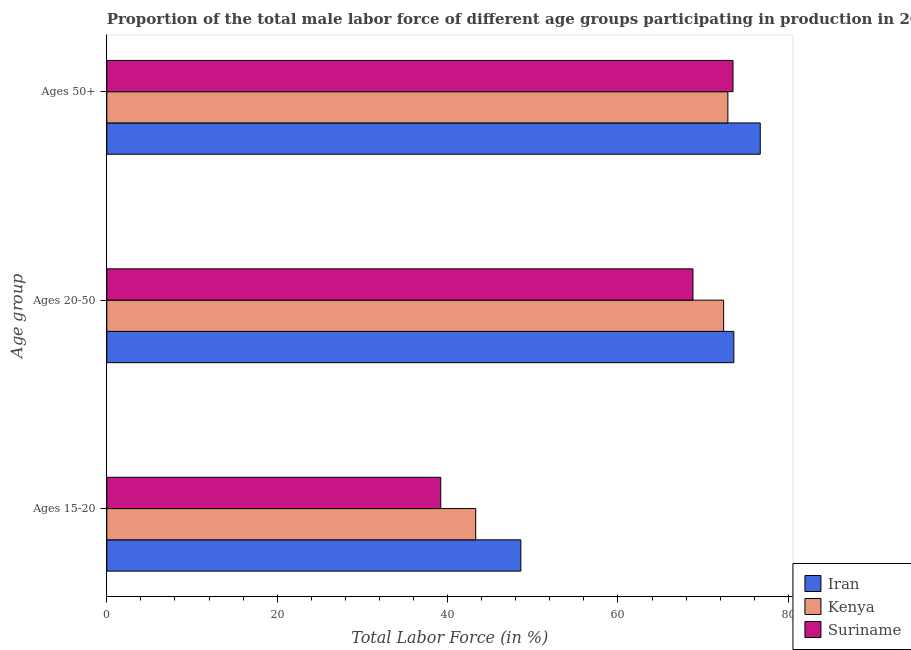How many different coloured bars are there?
Ensure brevity in your answer.  3. How many bars are there on the 1st tick from the bottom?
Offer a terse response. 3. What is the label of the 3rd group of bars from the top?
Make the answer very short. Ages 15-20. What is the percentage of male labor force within the age group 15-20 in Kenya?
Provide a succinct answer. 43.3. Across all countries, what is the maximum percentage of male labor force within the age group 15-20?
Provide a succinct answer. 48.6. Across all countries, what is the minimum percentage of male labor force within the age group 20-50?
Your answer should be compact. 68.8. In which country was the percentage of male labor force within the age group 15-20 maximum?
Provide a short and direct response. Iran. In which country was the percentage of male labor force above age 50 minimum?
Offer a terse response. Kenya. What is the total percentage of male labor force within the age group 20-50 in the graph?
Provide a short and direct response. 214.8. What is the difference between the percentage of male labor force within the age group 15-20 in Iran and that in Suriname?
Offer a very short reply. 9.4. What is the difference between the percentage of male labor force within the age group 20-50 in Suriname and the percentage of male labor force above age 50 in Iran?
Offer a very short reply. -7.9. What is the average percentage of male labor force within the age group 20-50 per country?
Your answer should be compact. 71.6. What is the difference between the percentage of male labor force within the age group 20-50 and percentage of male labor force above age 50 in Iran?
Make the answer very short. -3.1. What is the ratio of the percentage of male labor force within the age group 15-20 in Suriname to that in Iran?
Make the answer very short. 0.81. Is the percentage of male labor force within the age group 15-20 in Suriname less than that in Iran?
Your answer should be compact. Yes. Is the difference between the percentage of male labor force within the age group 20-50 in Suriname and Iran greater than the difference between the percentage of male labor force above age 50 in Suriname and Iran?
Provide a succinct answer. No. What is the difference between the highest and the second highest percentage of male labor force within the age group 20-50?
Your answer should be compact. 1.2. What is the difference between the highest and the lowest percentage of male labor force above age 50?
Make the answer very short. 3.8. In how many countries, is the percentage of male labor force above age 50 greater than the average percentage of male labor force above age 50 taken over all countries?
Give a very brief answer. 1. Is the sum of the percentage of male labor force above age 50 in Kenya and Suriname greater than the maximum percentage of male labor force within the age group 20-50 across all countries?
Keep it short and to the point. Yes. What does the 2nd bar from the top in Ages 20-50 represents?
Provide a succinct answer. Kenya. What does the 3rd bar from the bottom in Ages 15-20 represents?
Make the answer very short. Suriname. Is it the case that in every country, the sum of the percentage of male labor force within the age group 15-20 and percentage of male labor force within the age group 20-50 is greater than the percentage of male labor force above age 50?
Your answer should be compact. Yes. Are all the bars in the graph horizontal?
Your answer should be compact. Yes. How many countries are there in the graph?
Make the answer very short. 3. Does the graph contain any zero values?
Give a very brief answer. No. Does the graph contain grids?
Keep it short and to the point. No. What is the title of the graph?
Offer a very short reply. Proportion of the total male labor force of different age groups participating in production in 2013. What is the label or title of the Y-axis?
Your answer should be compact. Age group. What is the Total Labor Force (in %) of Iran in Ages 15-20?
Your answer should be compact. 48.6. What is the Total Labor Force (in %) of Kenya in Ages 15-20?
Make the answer very short. 43.3. What is the Total Labor Force (in %) of Suriname in Ages 15-20?
Ensure brevity in your answer.  39.2. What is the Total Labor Force (in %) in Iran in Ages 20-50?
Offer a very short reply. 73.6. What is the Total Labor Force (in %) of Kenya in Ages 20-50?
Your response must be concise. 72.4. What is the Total Labor Force (in %) of Suriname in Ages 20-50?
Your response must be concise. 68.8. What is the Total Labor Force (in %) of Iran in Ages 50+?
Your answer should be compact. 76.7. What is the Total Labor Force (in %) of Kenya in Ages 50+?
Make the answer very short. 72.9. What is the Total Labor Force (in %) of Suriname in Ages 50+?
Keep it short and to the point. 73.5. Across all Age group, what is the maximum Total Labor Force (in %) in Iran?
Keep it short and to the point. 76.7. Across all Age group, what is the maximum Total Labor Force (in %) in Kenya?
Your answer should be compact. 72.9. Across all Age group, what is the maximum Total Labor Force (in %) in Suriname?
Offer a very short reply. 73.5. Across all Age group, what is the minimum Total Labor Force (in %) in Iran?
Provide a succinct answer. 48.6. Across all Age group, what is the minimum Total Labor Force (in %) of Kenya?
Keep it short and to the point. 43.3. Across all Age group, what is the minimum Total Labor Force (in %) in Suriname?
Give a very brief answer. 39.2. What is the total Total Labor Force (in %) of Iran in the graph?
Your answer should be compact. 198.9. What is the total Total Labor Force (in %) of Kenya in the graph?
Offer a terse response. 188.6. What is the total Total Labor Force (in %) in Suriname in the graph?
Provide a succinct answer. 181.5. What is the difference between the Total Labor Force (in %) of Iran in Ages 15-20 and that in Ages 20-50?
Your answer should be very brief. -25. What is the difference between the Total Labor Force (in %) in Kenya in Ages 15-20 and that in Ages 20-50?
Provide a succinct answer. -29.1. What is the difference between the Total Labor Force (in %) of Suriname in Ages 15-20 and that in Ages 20-50?
Your answer should be very brief. -29.6. What is the difference between the Total Labor Force (in %) in Iran in Ages 15-20 and that in Ages 50+?
Provide a short and direct response. -28.1. What is the difference between the Total Labor Force (in %) of Kenya in Ages 15-20 and that in Ages 50+?
Give a very brief answer. -29.6. What is the difference between the Total Labor Force (in %) in Suriname in Ages 15-20 and that in Ages 50+?
Offer a terse response. -34.3. What is the difference between the Total Labor Force (in %) in Kenya in Ages 20-50 and that in Ages 50+?
Ensure brevity in your answer.  -0.5. What is the difference between the Total Labor Force (in %) in Suriname in Ages 20-50 and that in Ages 50+?
Provide a short and direct response. -4.7. What is the difference between the Total Labor Force (in %) in Iran in Ages 15-20 and the Total Labor Force (in %) in Kenya in Ages 20-50?
Provide a succinct answer. -23.8. What is the difference between the Total Labor Force (in %) in Iran in Ages 15-20 and the Total Labor Force (in %) in Suriname in Ages 20-50?
Ensure brevity in your answer.  -20.2. What is the difference between the Total Labor Force (in %) of Kenya in Ages 15-20 and the Total Labor Force (in %) of Suriname in Ages 20-50?
Your answer should be very brief. -25.5. What is the difference between the Total Labor Force (in %) in Iran in Ages 15-20 and the Total Labor Force (in %) in Kenya in Ages 50+?
Provide a short and direct response. -24.3. What is the difference between the Total Labor Force (in %) in Iran in Ages 15-20 and the Total Labor Force (in %) in Suriname in Ages 50+?
Ensure brevity in your answer.  -24.9. What is the difference between the Total Labor Force (in %) of Kenya in Ages 15-20 and the Total Labor Force (in %) of Suriname in Ages 50+?
Provide a short and direct response. -30.2. What is the difference between the Total Labor Force (in %) in Iran in Ages 20-50 and the Total Labor Force (in %) in Kenya in Ages 50+?
Your answer should be very brief. 0.7. What is the difference between the Total Labor Force (in %) of Kenya in Ages 20-50 and the Total Labor Force (in %) of Suriname in Ages 50+?
Offer a terse response. -1.1. What is the average Total Labor Force (in %) of Iran per Age group?
Offer a very short reply. 66.3. What is the average Total Labor Force (in %) of Kenya per Age group?
Give a very brief answer. 62.87. What is the average Total Labor Force (in %) of Suriname per Age group?
Keep it short and to the point. 60.5. What is the difference between the Total Labor Force (in %) in Kenya and Total Labor Force (in %) in Suriname in Ages 15-20?
Ensure brevity in your answer.  4.1. What is the difference between the Total Labor Force (in %) in Iran and Total Labor Force (in %) in Kenya in Ages 20-50?
Ensure brevity in your answer.  1.2. What is the difference between the Total Labor Force (in %) in Iran and Total Labor Force (in %) in Suriname in Ages 20-50?
Provide a succinct answer. 4.8. What is the difference between the Total Labor Force (in %) in Iran and Total Labor Force (in %) in Suriname in Ages 50+?
Ensure brevity in your answer.  3.2. What is the ratio of the Total Labor Force (in %) of Iran in Ages 15-20 to that in Ages 20-50?
Make the answer very short. 0.66. What is the ratio of the Total Labor Force (in %) of Kenya in Ages 15-20 to that in Ages 20-50?
Keep it short and to the point. 0.6. What is the ratio of the Total Labor Force (in %) in Suriname in Ages 15-20 to that in Ages 20-50?
Provide a short and direct response. 0.57. What is the ratio of the Total Labor Force (in %) in Iran in Ages 15-20 to that in Ages 50+?
Keep it short and to the point. 0.63. What is the ratio of the Total Labor Force (in %) of Kenya in Ages 15-20 to that in Ages 50+?
Offer a terse response. 0.59. What is the ratio of the Total Labor Force (in %) of Suriname in Ages 15-20 to that in Ages 50+?
Offer a terse response. 0.53. What is the ratio of the Total Labor Force (in %) in Iran in Ages 20-50 to that in Ages 50+?
Your answer should be compact. 0.96. What is the ratio of the Total Labor Force (in %) of Kenya in Ages 20-50 to that in Ages 50+?
Provide a succinct answer. 0.99. What is the ratio of the Total Labor Force (in %) in Suriname in Ages 20-50 to that in Ages 50+?
Keep it short and to the point. 0.94. What is the difference between the highest and the second highest Total Labor Force (in %) in Suriname?
Provide a short and direct response. 4.7. What is the difference between the highest and the lowest Total Labor Force (in %) of Iran?
Provide a succinct answer. 28.1. What is the difference between the highest and the lowest Total Labor Force (in %) of Kenya?
Give a very brief answer. 29.6. What is the difference between the highest and the lowest Total Labor Force (in %) in Suriname?
Offer a terse response. 34.3. 